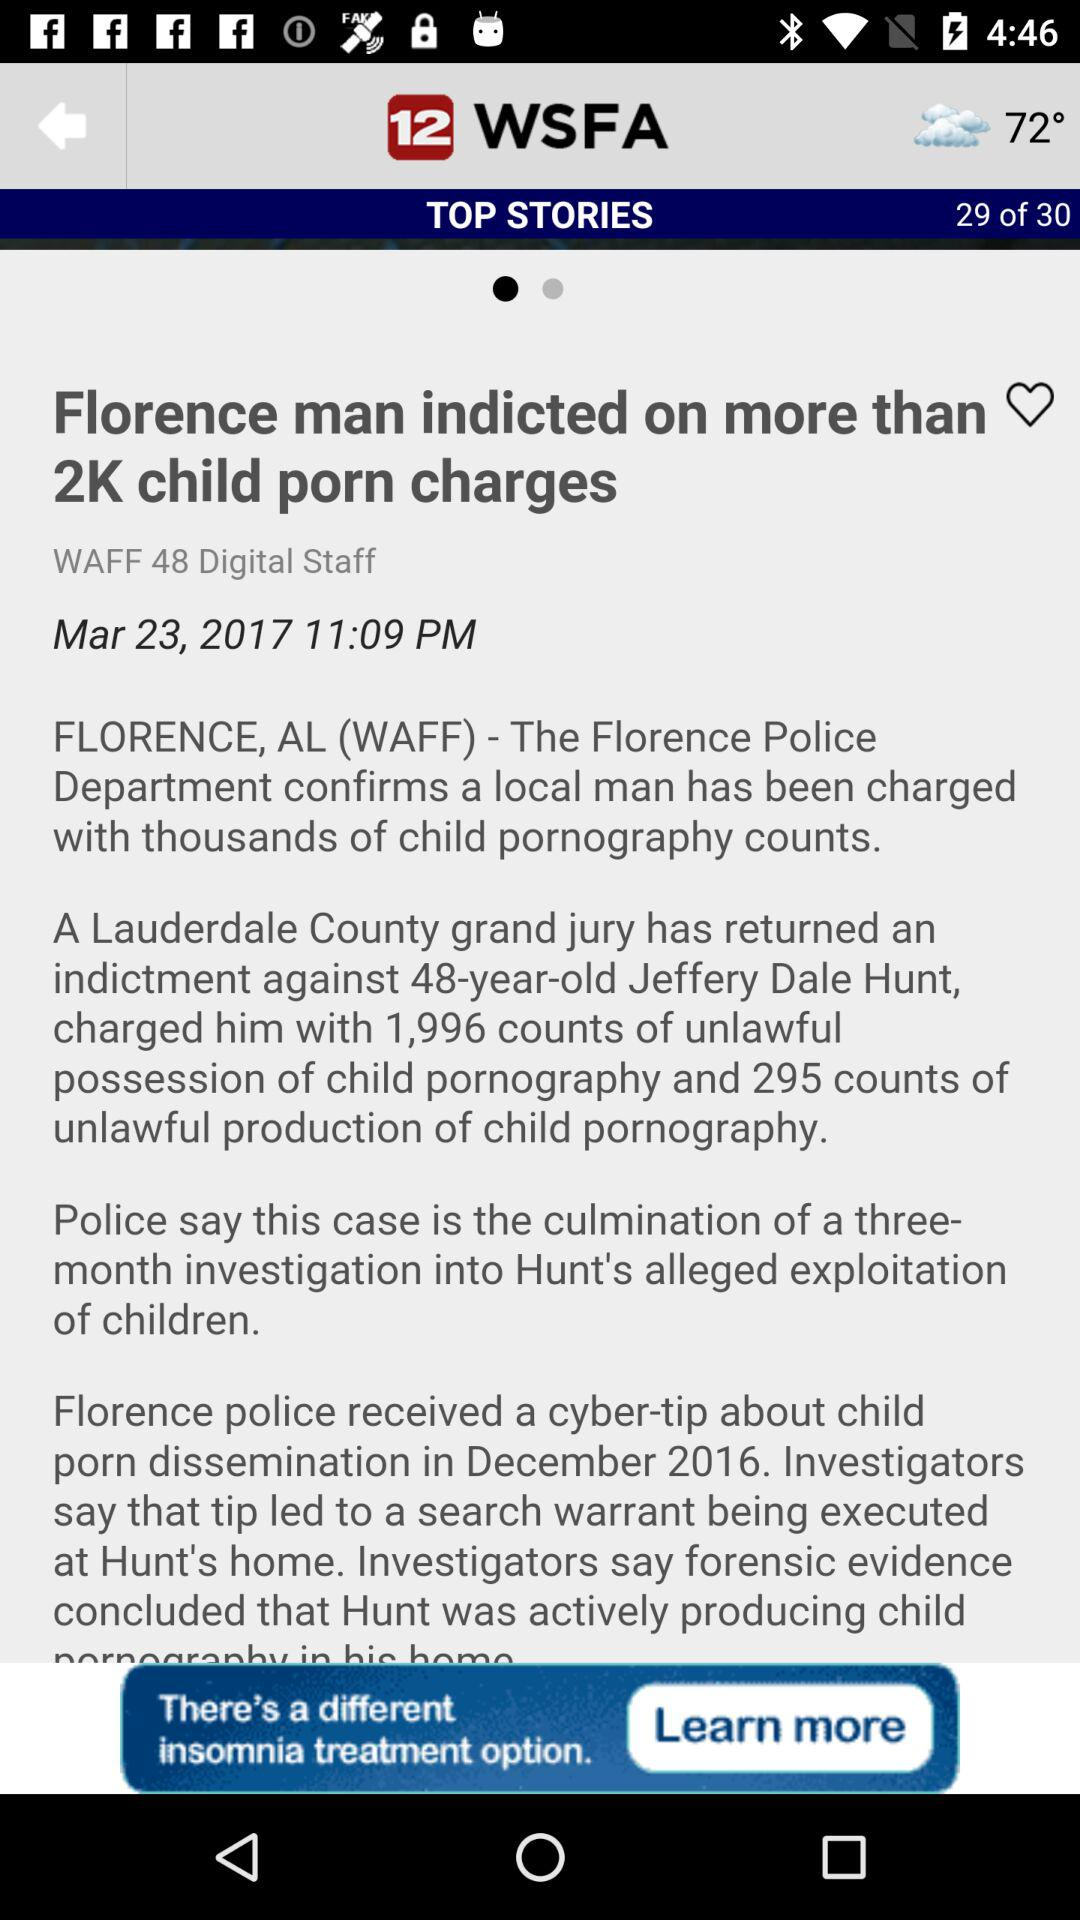What is the temperature? The temperature is 72°. 